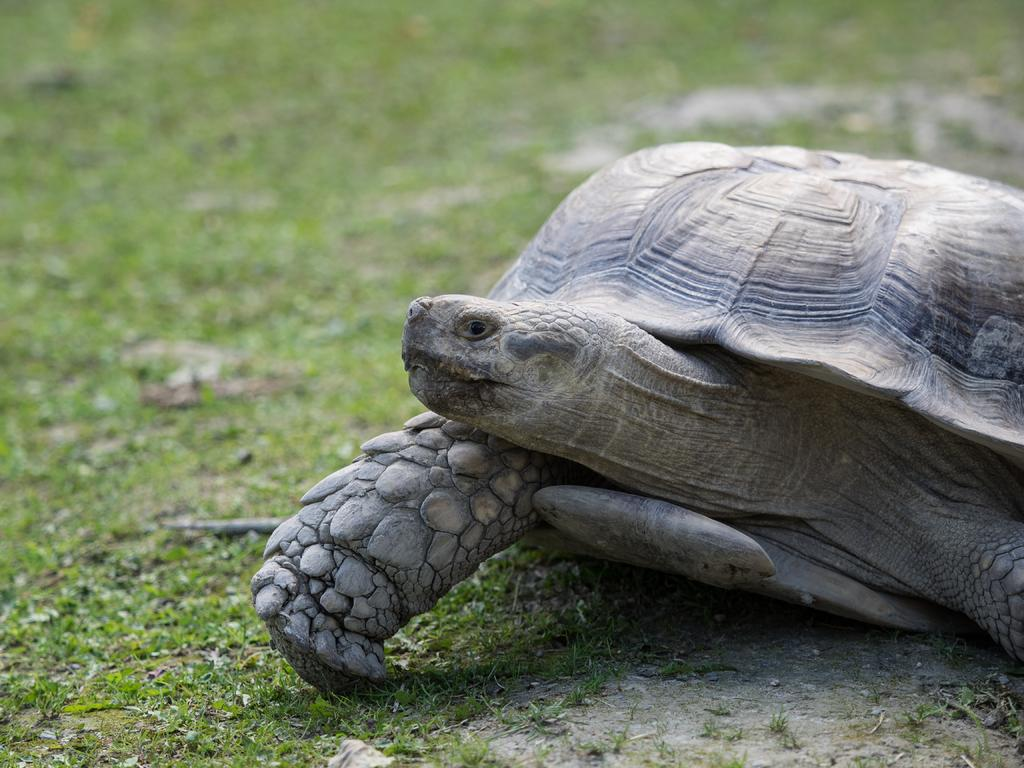What animal is in the foreground of the image? There is a tortoise in the foreground of the image. On which side of the image is the tortoise located? The tortoise is on the right side of the image. What type of vegetation can be seen in the background of the image? There is grass visible in the background of the image. What type of cherry is being baked in the oven in the image? There is no oven or cherry present in the image; it features a tortoise on the right side of the image with grass in the background. 